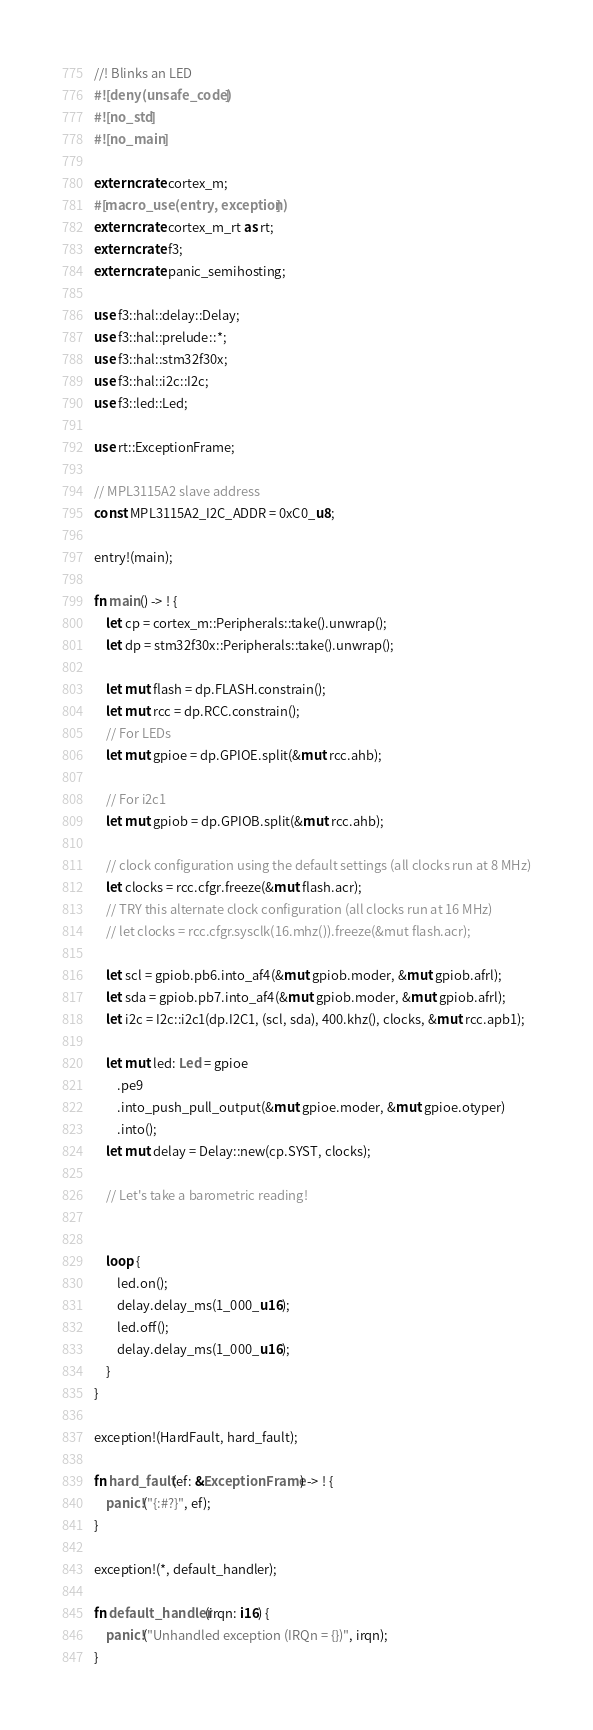<code> <loc_0><loc_0><loc_500><loc_500><_Rust_>//! Blinks an LED
#![deny(unsafe_code)]
#![no_std]
#![no_main]

extern crate cortex_m;
#[macro_use(entry, exception)]
extern crate cortex_m_rt as rt;
extern crate f3;
extern crate panic_semihosting;

use f3::hal::delay::Delay;
use f3::hal::prelude::*;
use f3::hal::stm32f30x;
use f3::hal::i2c::I2c;
use f3::led::Led;

use rt::ExceptionFrame;

// MPL3115A2 slave address
const MPL3115A2_I2C_ADDR = 0xC0_u8;

entry!(main);

fn main() -> ! {
    let cp = cortex_m::Peripherals::take().unwrap();
    let dp = stm32f30x::Peripherals::take().unwrap();

    let mut flash = dp.FLASH.constrain();
    let mut rcc = dp.RCC.constrain();
    // For LEDs
    let mut gpioe = dp.GPIOE.split(&mut rcc.ahb);

    // For i2c1
    let mut gpiob = dp.GPIOB.split(&mut rcc.ahb);

    // clock configuration using the default settings (all clocks run at 8 MHz)
    let clocks = rcc.cfgr.freeze(&mut flash.acr);
    // TRY this alternate clock configuration (all clocks run at 16 MHz)
    // let clocks = rcc.cfgr.sysclk(16.mhz()).freeze(&mut flash.acr);

    let scl = gpiob.pb6.into_af4(&mut gpiob.moder, &mut gpiob.afrl);
    let sda = gpiob.pb7.into_af4(&mut gpiob.moder, &mut gpiob.afrl);
    let i2c = I2c::i2c1(dp.I2C1, (scl, sda), 400.khz(), clocks, &mut rcc.apb1);

    let mut led: Led = gpioe
        .pe9
        .into_push_pull_output(&mut gpioe.moder, &mut gpioe.otyper)
        .into();
    let mut delay = Delay::new(cp.SYST, clocks);

    // Let's take a barometric reading!
    

    loop {
        led.on();
        delay.delay_ms(1_000_u16);
        led.off();
        delay.delay_ms(1_000_u16);
    }
}

exception!(HardFault, hard_fault);

fn hard_fault(ef: &ExceptionFrame) -> ! {
    panic!("{:#?}", ef);
}

exception!(*, default_handler);

fn default_handler(irqn: i16) {
    panic!("Unhandled exception (IRQn = {})", irqn);
}
</code> 